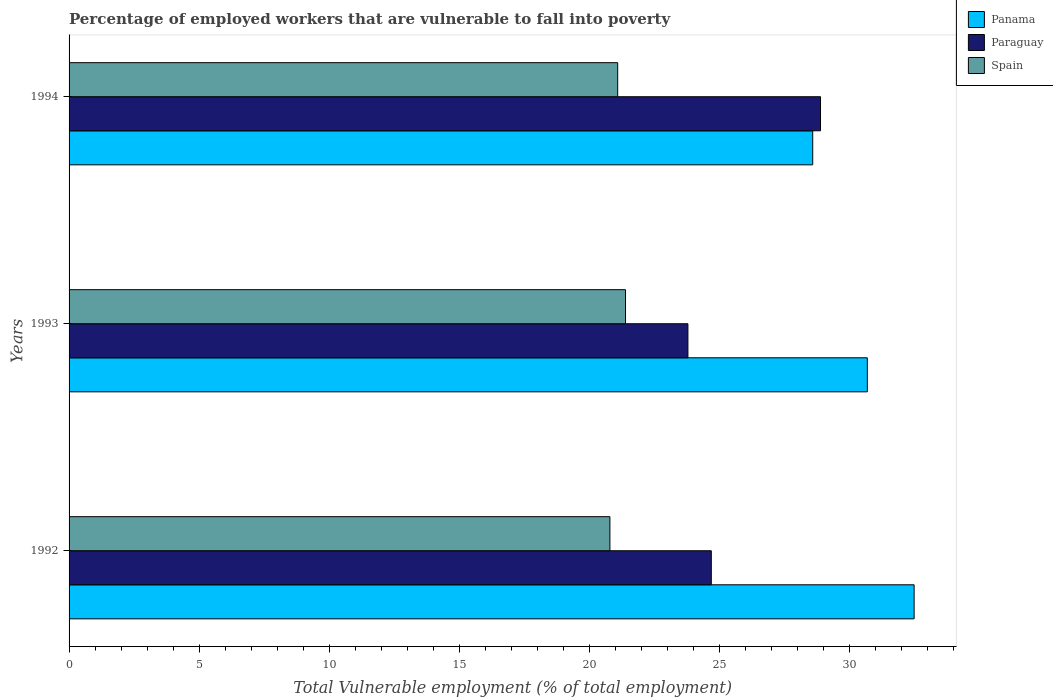Are the number of bars per tick equal to the number of legend labels?
Your response must be concise. Yes. How many bars are there on the 1st tick from the top?
Offer a very short reply. 3. What is the label of the 3rd group of bars from the top?
Offer a terse response. 1992. In how many cases, is the number of bars for a given year not equal to the number of legend labels?
Ensure brevity in your answer.  0. What is the percentage of employed workers who are vulnerable to fall into poverty in Spain in 1992?
Provide a succinct answer. 20.8. Across all years, what is the maximum percentage of employed workers who are vulnerable to fall into poverty in Panama?
Your response must be concise. 32.5. Across all years, what is the minimum percentage of employed workers who are vulnerable to fall into poverty in Panama?
Give a very brief answer. 28.6. In which year was the percentage of employed workers who are vulnerable to fall into poverty in Panama maximum?
Offer a terse response. 1992. What is the total percentage of employed workers who are vulnerable to fall into poverty in Spain in the graph?
Your answer should be compact. 63.3. What is the difference between the percentage of employed workers who are vulnerable to fall into poverty in Paraguay in 1992 and that in 1993?
Your answer should be compact. 0.9. What is the difference between the percentage of employed workers who are vulnerable to fall into poverty in Spain in 1994 and the percentage of employed workers who are vulnerable to fall into poverty in Panama in 1993?
Your answer should be compact. -9.6. What is the average percentage of employed workers who are vulnerable to fall into poverty in Paraguay per year?
Offer a terse response. 25.8. In the year 1994, what is the difference between the percentage of employed workers who are vulnerable to fall into poverty in Panama and percentage of employed workers who are vulnerable to fall into poverty in Spain?
Your answer should be very brief. 7.5. What is the ratio of the percentage of employed workers who are vulnerable to fall into poverty in Spain in 1993 to that in 1994?
Ensure brevity in your answer.  1.01. What is the difference between the highest and the second highest percentage of employed workers who are vulnerable to fall into poverty in Paraguay?
Keep it short and to the point. 4.2. What is the difference between the highest and the lowest percentage of employed workers who are vulnerable to fall into poverty in Paraguay?
Offer a terse response. 5.1. In how many years, is the percentage of employed workers who are vulnerable to fall into poverty in Spain greater than the average percentage of employed workers who are vulnerable to fall into poverty in Spain taken over all years?
Offer a terse response. 2. Is the sum of the percentage of employed workers who are vulnerable to fall into poverty in Paraguay in 1993 and 1994 greater than the maximum percentage of employed workers who are vulnerable to fall into poverty in Spain across all years?
Ensure brevity in your answer.  Yes. What does the 1st bar from the bottom in 1993 represents?
Provide a short and direct response. Panama. Is it the case that in every year, the sum of the percentage of employed workers who are vulnerable to fall into poverty in Spain and percentage of employed workers who are vulnerable to fall into poverty in Paraguay is greater than the percentage of employed workers who are vulnerable to fall into poverty in Panama?
Keep it short and to the point. Yes. How many bars are there?
Give a very brief answer. 9. How many years are there in the graph?
Your answer should be compact. 3. What is the difference between two consecutive major ticks on the X-axis?
Offer a very short reply. 5. Are the values on the major ticks of X-axis written in scientific E-notation?
Offer a very short reply. No. Does the graph contain any zero values?
Provide a succinct answer. No. What is the title of the graph?
Your answer should be very brief. Percentage of employed workers that are vulnerable to fall into poverty. What is the label or title of the X-axis?
Offer a very short reply. Total Vulnerable employment (% of total employment). What is the Total Vulnerable employment (% of total employment) in Panama in 1992?
Make the answer very short. 32.5. What is the Total Vulnerable employment (% of total employment) in Paraguay in 1992?
Your answer should be very brief. 24.7. What is the Total Vulnerable employment (% of total employment) in Spain in 1992?
Your answer should be compact. 20.8. What is the Total Vulnerable employment (% of total employment) of Panama in 1993?
Give a very brief answer. 30.7. What is the Total Vulnerable employment (% of total employment) of Paraguay in 1993?
Your answer should be very brief. 23.8. What is the Total Vulnerable employment (% of total employment) of Spain in 1993?
Offer a very short reply. 21.4. What is the Total Vulnerable employment (% of total employment) in Panama in 1994?
Make the answer very short. 28.6. What is the Total Vulnerable employment (% of total employment) in Paraguay in 1994?
Offer a very short reply. 28.9. What is the Total Vulnerable employment (% of total employment) of Spain in 1994?
Ensure brevity in your answer.  21.1. Across all years, what is the maximum Total Vulnerable employment (% of total employment) of Panama?
Your answer should be very brief. 32.5. Across all years, what is the maximum Total Vulnerable employment (% of total employment) in Paraguay?
Give a very brief answer. 28.9. Across all years, what is the maximum Total Vulnerable employment (% of total employment) of Spain?
Your answer should be compact. 21.4. Across all years, what is the minimum Total Vulnerable employment (% of total employment) in Panama?
Your answer should be compact. 28.6. Across all years, what is the minimum Total Vulnerable employment (% of total employment) of Paraguay?
Offer a terse response. 23.8. Across all years, what is the minimum Total Vulnerable employment (% of total employment) in Spain?
Offer a very short reply. 20.8. What is the total Total Vulnerable employment (% of total employment) of Panama in the graph?
Keep it short and to the point. 91.8. What is the total Total Vulnerable employment (% of total employment) of Paraguay in the graph?
Your answer should be compact. 77.4. What is the total Total Vulnerable employment (% of total employment) in Spain in the graph?
Your answer should be compact. 63.3. What is the difference between the Total Vulnerable employment (% of total employment) in Spain in 1992 and that in 1993?
Provide a succinct answer. -0.6. What is the difference between the Total Vulnerable employment (% of total employment) in Spain in 1992 and that in 1994?
Offer a very short reply. -0.3. What is the difference between the Total Vulnerable employment (% of total employment) in Panama in 1993 and that in 1994?
Your answer should be compact. 2.1. What is the difference between the Total Vulnerable employment (% of total employment) in Paraguay in 1993 and that in 1994?
Your response must be concise. -5.1. What is the difference between the Total Vulnerable employment (% of total employment) of Spain in 1993 and that in 1994?
Make the answer very short. 0.3. What is the difference between the Total Vulnerable employment (% of total employment) in Paraguay in 1992 and the Total Vulnerable employment (% of total employment) in Spain in 1993?
Your answer should be very brief. 3.3. What is the difference between the Total Vulnerable employment (% of total employment) of Panama in 1992 and the Total Vulnerable employment (% of total employment) of Spain in 1994?
Ensure brevity in your answer.  11.4. What is the difference between the Total Vulnerable employment (% of total employment) of Paraguay in 1992 and the Total Vulnerable employment (% of total employment) of Spain in 1994?
Provide a succinct answer. 3.6. What is the difference between the Total Vulnerable employment (% of total employment) in Panama in 1993 and the Total Vulnerable employment (% of total employment) in Paraguay in 1994?
Make the answer very short. 1.8. What is the difference between the Total Vulnerable employment (% of total employment) in Paraguay in 1993 and the Total Vulnerable employment (% of total employment) in Spain in 1994?
Make the answer very short. 2.7. What is the average Total Vulnerable employment (% of total employment) of Panama per year?
Your answer should be compact. 30.6. What is the average Total Vulnerable employment (% of total employment) in Paraguay per year?
Make the answer very short. 25.8. What is the average Total Vulnerable employment (% of total employment) of Spain per year?
Provide a succinct answer. 21.1. In the year 1992, what is the difference between the Total Vulnerable employment (% of total employment) in Panama and Total Vulnerable employment (% of total employment) in Spain?
Offer a terse response. 11.7. In the year 1993, what is the difference between the Total Vulnerable employment (% of total employment) of Paraguay and Total Vulnerable employment (% of total employment) of Spain?
Offer a terse response. 2.4. In the year 1994, what is the difference between the Total Vulnerable employment (% of total employment) of Panama and Total Vulnerable employment (% of total employment) of Paraguay?
Provide a succinct answer. -0.3. What is the ratio of the Total Vulnerable employment (% of total employment) in Panama in 1992 to that in 1993?
Offer a very short reply. 1.06. What is the ratio of the Total Vulnerable employment (% of total employment) of Paraguay in 1992 to that in 1993?
Provide a succinct answer. 1.04. What is the ratio of the Total Vulnerable employment (% of total employment) in Spain in 1992 to that in 1993?
Make the answer very short. 0.97. What is the ratio of the Total Vulnerable employment (% of total employment) in Panama in 1992 to that in 1994?
Your answer should be compact. 1.14. What is the ratio of the Total Vulnerable employment (% of total employment) of Paraguay in 1992 to that in 1994?
Your response must be concise. 0.85. What is the ratio of the Total Vulnerable employment (% of total employment) in Spain in 1992 to that in 1994?
Provide a short and direct response. 0.99. What is the ratio of the Total Vulnerable employment (% of total employment) of Panama in 1993 to that in 1994?
Give a very brief answer. 1.07. What is the ratio of the Total Vulnerable employment (% of total employment) of Paraguay in 1993 to that in 1994?
Provide a succinct answer. 0.82. What is the ratio of the Total Vulnerable employment (% of total employment) of Spain in 1993 to that in 1994?
Offer a terse response. 1.01. What is the difference between the highest and the second highest Total Vulnerable employment (% of total employment) in Paraguay?
Your answer should be compact. 4.2. What is the difference between the highest and the second highest Total Vulnerable employment (% of total employment) in Spain?
Your answer should be compact. 0.3. What is the difference between the highest and the lowest Total Vulnerable employment (% of total employment) in Panama?
Your answer should be compact. 3.9. 